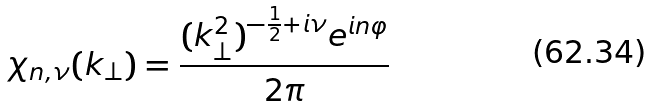<formula> <loc_0><loc_0><loc_500><loc_500>\chi _ { n , \nu } ( k _ { \perp } ) = \frac { ( k _ { \perp } ^ { 2 } ) ^ { - \frac { 1 } { 2 } + i \nu } e ^ { i n \varphi } } { 2 \pi }</formula> 